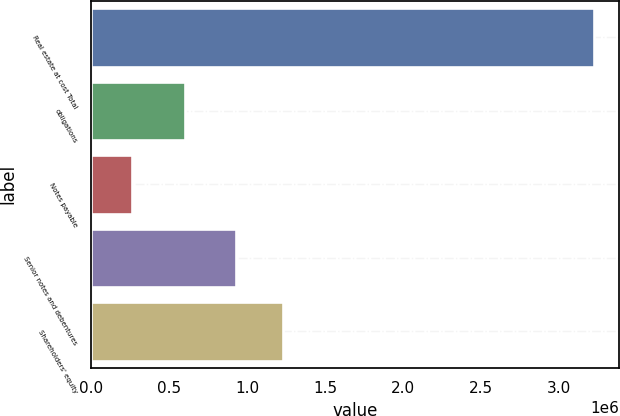Convert chart to OTSL. <chart><loc_0><loc_0><loc_500><loc_500><bar_chart><fcel>Real estate at cost Total<fcel>obligations<fcel>Notes payable<fcel>Senior notes and debentures<fcel>Shareholders' equity<nl><fcel>3.22231e+06<fcel>601884<fcel>261745<fcel>930219<fcel>1.22628e+06<nl></chart> 